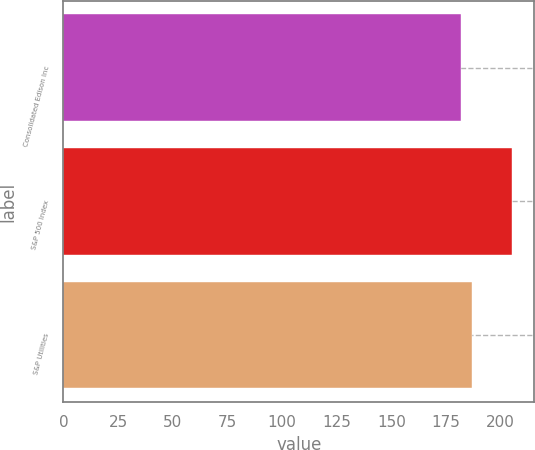<chart> <loc_0><loc_0><loc_500><loc_500><bar_chart><fcel>Consolidated Edison Inc<fcel>S&P 500 Index<fcel>S&P Utilities<nl><fcel>181.63<fcel>205.14<fcel>187.04<nl></chart> 